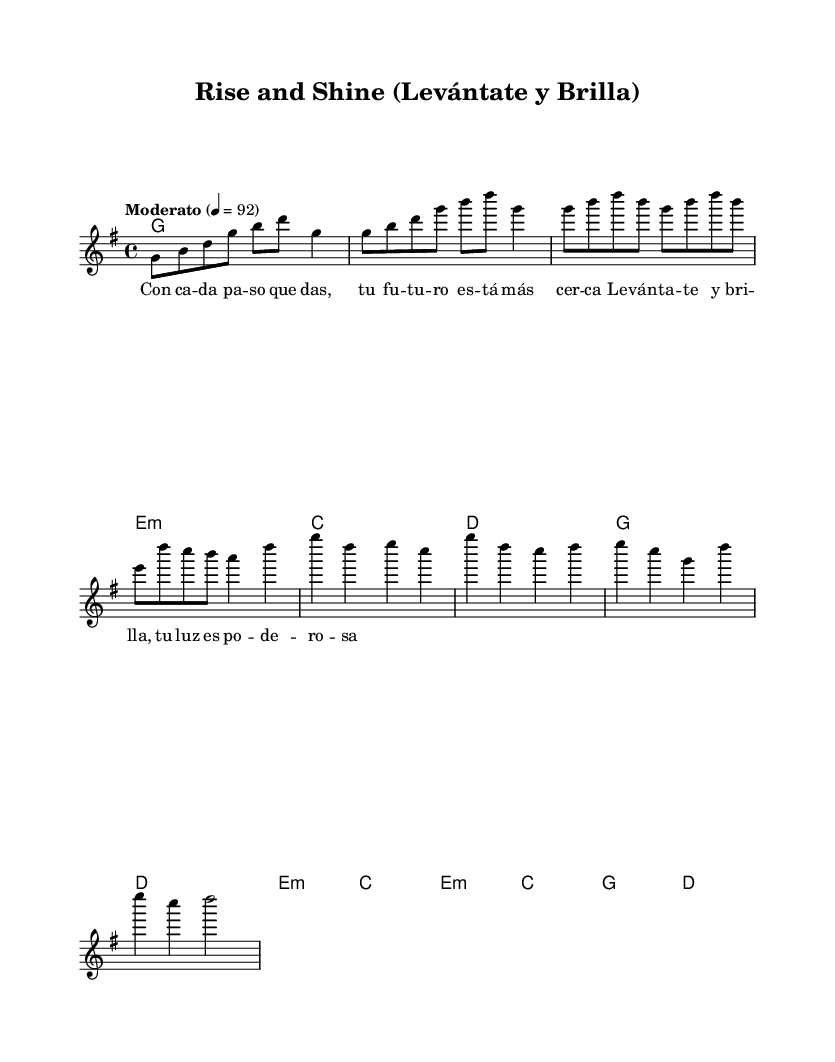What is the key signature of this music? The key signature is G major, which has one sharp (F#). This can be identified by looking at the key signature located at the beginning of the staff.
Answer: G major What is the time signature of this music? The time signature is 4/4, which indicates four beats in each measure and a quarter note receives one beat. This is found at the beginning of the piece next to the key signature.
Answer: 4/4 What is the tempo marking for this piece? The tempo marking is "Moderato," indicating a moderate speed, and it specifies a metronome marking of 92 beats per minute. This is mentioned at the beginning of the score.
Answer: Moderato How many measures does the verse contain? The verse contains four measures, which can be counted by identifying the measure bars within the section labeled as "Verse."
Answer: Four measures What role do the harmonies play in this music? The harmonies provide a structural support and enhance the melodic line by outlining the chord progressions throughout the piece, specifically through the use of chord modes.
Answer: Structural support What language are the lyrics written in? The lyrics are written in Spanish, as indicated by the use of Spanish language words and phrases throughout the piece.
Answer: Spanish What emotion or theme is portrayed by the title "Rise and Shine"? The title suggests themes of empowerment and positivity, which is reflected in the uplifting nature of both the title and the lyrics, motivating youth to feel empowered.
Answer: Empowerment 